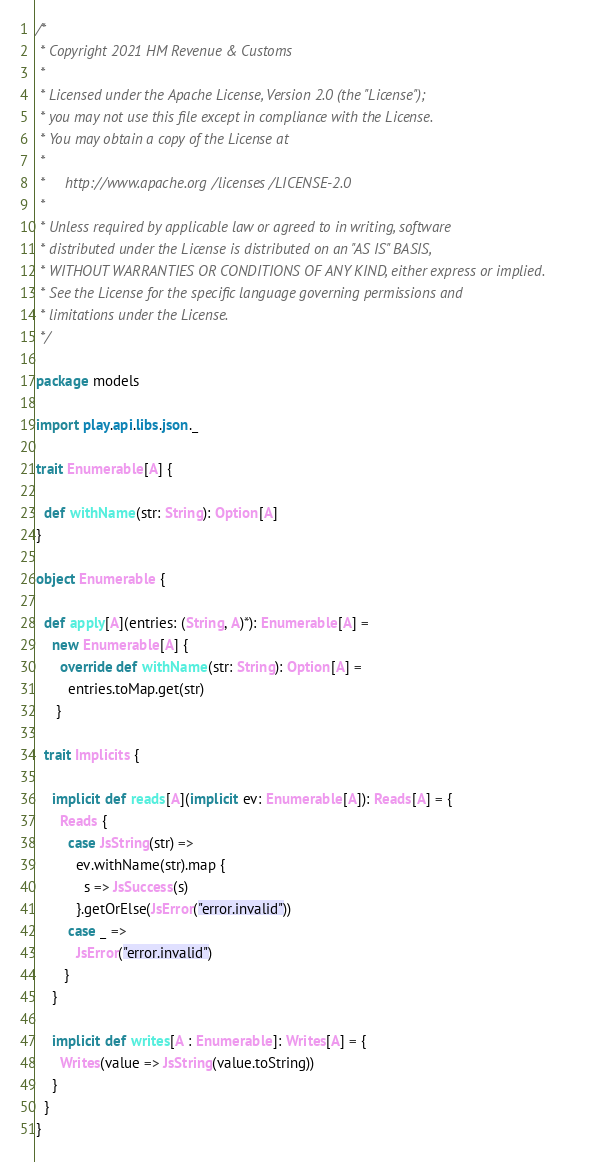Convert code to text. <code><loc_0><loc_0><loc_500><loc_500><_Scala_>/*
 * Copyright 2021 HM Revenue & Customs
 *
 * Licensed under the Apache License, Version 2.0 (the "License");
 * you may not use this file except in compliance with the License.
 * You may obtain a copy of the License at
 *
 *     http://www.apache.org/licenses/LICENSE-2.0
 *
 * Unless required by applicable law or agreed to in writing, software
 * distributed under the License is distributed on an "AS IS" BASIS,
 * WITHOUT WARRANTIES OR CONDITIONS OF ANY KIND, either express or implied.
 * See the License for the specific language governing permissions and
 * limitations under the License.
 */

package models

import play.api.libs.json._

trait Enumerable[A] {

  def withName(str: String): Option[A]
}

object Enumerable {

  def apply[A](entries: (String, A)*): Enumerable[A] =
    new Enumerable[A] {
      override def withName(str: String): Option[A] =
        entries.toMap.get(str)
     }

  trait Implicits {

    implicit def reads[A](implicit ev: Enumerable[A]): Reads[A] = {
      Reads {
        case JsString(str) =>
          ev.withName(str).map {
            s => JsSuccess(s)
          }.getOrElse(JsError("error.invalid"))
        case _ =>
          JsError("error.invalid")
       }
    }

    implicit def writes[A : Enumerable]: Writes[A] = {
      Writes(value => JsString(value.toString))
    }
  }
}
</code> 